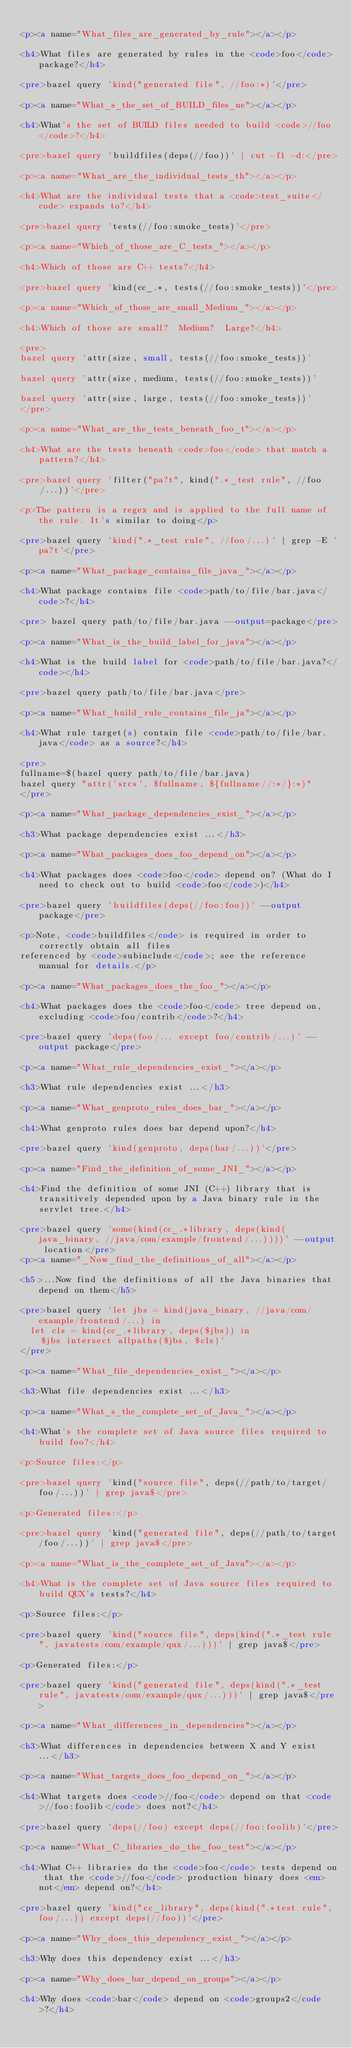Convert code to text. <code><loc_0><loc_0><loc_500><loc_500><_HTML_>
<p><a name="What_files_are_generated_by_rule"></a></p>

<h4>What files are generated by rules in the <code>foo</code> package?</h4>

<pre>bazel query 'kind("generated file", //foo:*)'</pre>

<p><a name="What_s_the_set_of_BUILD_files_ne"></a></p>

<h4>What's the set of BUILD files needed to build <code>//foo</code>?</h4>

<pre>bazel query 'buildfiles(deps(//foo))' | cut -f1 -d:</pre>

<p><a name="What_are_the_individual_tests_th"></a></p>

<h4>What are the individual tests that a <code>test_suite</code> expands to?</h4>

<pre>bazel query 'tests(//foo:smoke_tests)'</pre>

<p><a name="Which_of_those_are_C_tests_"></a></p>

<h4>Which of those are C++ tests?</h4>

<pre>bazel query 'kind(cc_.*, tests(//foo:smoke_tests))'</pre>

<p><a name="Which_of_those_are_small_Medium_"></a></p>

<h4>Which of those are small?  Medium?  Large?</h4>

<pre>
bazel query 'attr(size, small, tests(//foo:smoke_tests))'

bazel query 'attr(size, medium, tests(//foo:smoke_tests))'

bazel query 'attr(size, large, tests(//foo:smoke_tests))'
</pre>

<p><a name="What_are_the_tests_beneath_foo_t"></a></p>

<h4>What are the tests beneath <code>foo</code> that match a pattern?</h4>

<pre>bazel query 'filter("pa?t", kind(".*_test rule", //foo/...))'</pre>

<p>The pattern is a regex and is applied to the full name of the rule. It's similar to doing</p>

<pre>bazel query 'kind(".*_test rule", //foo/...)' | grep -E 'pa?t'</pre>

<p><a name="What_package_contains_file_java_"></a></p>

<h4>What package contains file <code>path/to/file/bar.java</code>?</h4>

<pre> bazel query path/to/file/bar.java --output=package</pre>

<p><a name="What_is_the_build_label_for_java"></a></p>

<h4>What is the build label for <code>path/to/file/bar.java?</code></h4>

<pre>bazel query path/to/file/bar.java</pre>

<p><a name="What_build_rule_contains_file_ja"></a></p>

<h4>What rule target(s) contain file <code>path/to/file/bar.java</code> as a source?</h4>

<pre>
fullname=$(bazel query path/to/file/bar.java)
bazel query "attr('srcs', $fullname, ${fullname//:*/}:*)"
</pre>

<p><a name="What_package_dependencies_exist_"></a></p>

<h3>What package dependencies exist ...</h3>

<p><a name="What_packages_does_foo_depend_on"></a></p>

<h4>What packages does <code>foo</code> depend on? (What do I need to check out to build <code>foo</code>)</h4>

<pre>bazel query 'buildfiles(deps(//foo:foo))' --output package</pre>

<p>Note, <code>buildfiles</code> is required in order to correctly obtain all files
referenced by <code>subinclude</code>; see the reference manual for details.</p>

<p><a name="What_packages_does_the_foo_"></a></p>

<h4>What packages does the <code>foo</code> tree depend on, excluding <code>foo/contrib</code>?</h4>

<pre>bazel query 'deps(foo/... except foo/contrib/...)' --output package</pre>

<p><a name="What_rule_dependencies_exist_"></a></p>

<h3>What rule dependencies exist ...</h3>

<p><a name="What_genproto_rules_does_bar_"></a></p>

<h4>What genproto rules does bar depend upon?</h4>

<pre>bazel query 'kind(genproto, deps(bar/...))'</pre>

<p><a name="Find_the_definition_of_some_JNI_"></a></p>

<h4>Find the definition of some JNI (C++) library that is transitively depended upon by a Java binary rule in the servlet tree.</h4>

<pre>bazel query 'some(kind(cc_.*library, deps(kind(java_binary, //java/com/example/frontend/...))))' --output location</pre>
<p><a name="_Now_find_the_definitions_of_all"></a></p>

<h5>...Now find the definitions of all the Java binaries that depend on them</h5>

<pre>bazel query 'let jbs = kind(java_binary, //java/com/example/frontend/...) in
  let cls = kind(cc_.*library, deps($jbs)) in
    $jbs intersect allpaths($jbs, $cls)'
</pre>

<p><a name="What_file_dependencies_exist_"></a></p>

<h3>What file dependencies exist ...</h3>

<p><a name="What_s_the_complete_set_of_Java_"></a></p>

<h4>What's the complete set of Java source files required to build foo?</h4>

<p>Source files:</p>

<pre>bazel query 'kind("source file", deps(//path/to/target/foo/...))' | grep java$</pre>

<p>Generated files:</p>

<pre>bazel query 'kind("generated file", deps(//path/to/target/foo/...))' | grep java$</pre>

<p><a name="What_is_the_complete_set_of_Java"></a></p>

<h4>What is the complete set of Java source files required to build QUX's tests?</h4>

<p>Source files:</p>

<pre>bazel query 'kind("source file", deps(kind(".*_test rule", javatests/com/example/qux/...)))' | grep java$</pre>

<p>Generated files:</p>

<pre>bazel query 'kind("generated file", deps(kind(".*_test rule", javatests/com/example/qux/...)))' | grep java$</pre>

<p><a name="What_differences_in_dependencies"></a></p>

<h3>What differences in dependencies between X and Y exist ...</h3>

<p><a name="What_targets_does_foo_depend_on_"></a></p>

<h4>What targets does <code>//foo</code> depend on that <code>//foo:foolib</code> does not?</h4>

<pre>bazel query 'deps(//foo) except deps(//foo:foolib)'</pre>

<p><a name="What_C_libraries_do_the_foo_test"></a></p>

<h4>What C++ libraries do the <code>foo</code> tests depend on that the <code>//foo</code> production binary does <em>not</em> depend on?</h4>

<pre>bazel query 'kind("cc_library", deps(kind(".*test rule", foo/...)) except deps(//foo))'</pre>

<p><a name="Why_does_this_dependency_exist_"></a></p>

<h3>Why does this dependency exist ...</h3>

<p><a name="Why_does_bar_depend_on_groups"></a></p>

<h4>Why does <code>bar</code> depend on <code>groups2</code>?</h4>
</code> 